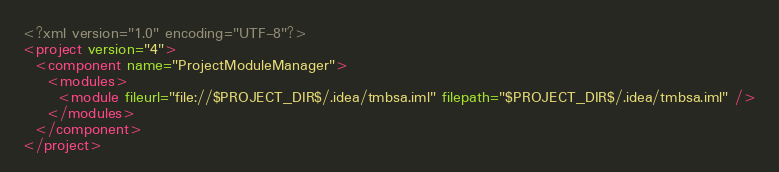<code> <loc_0><loc_0><loc_500><loc_500><_XML_><?xml version="1.0" encoding="UTF-8"?>
<project version="4">
  <component name="ProjectModuleManager">
    <modules>
      <module fileurl="file://$PROJECT_DIR$/.idea/tmbsa.iml" filepath="$PROJECT_DIR$/.idea/tmbsa.iml" />
    </modules>
  </component>
</project></code> 